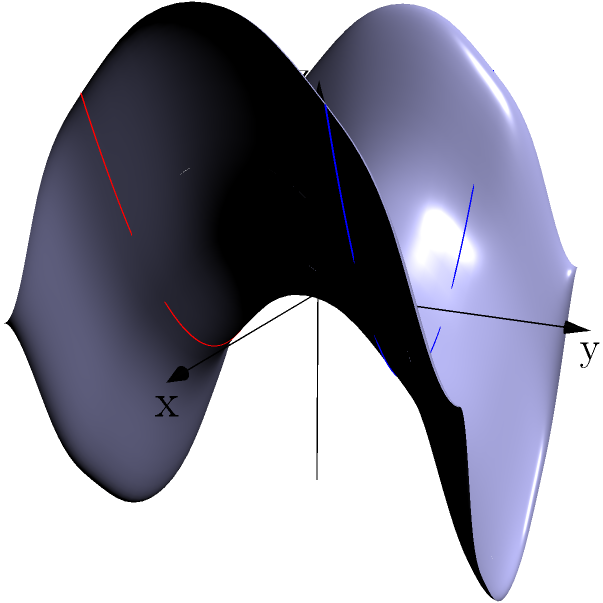On a saddle-shaped surface described by the equation $z = x^2 - y^2$, two lines are drawn parallel to the x-axis at $y = 1$ and $y = -1$. How do these lines behave compared to parallel lines on a flat Euclidean plane? To understand the behavior of these lines, let's follow these steps:

1) In Euclidean geometry, parallel lines maintain a constant distance from each other and never intersect.

2) The saddle surface is described by $z = x^2 - y^2$. This is a hyperbolic paraboloid, a non-Euclidean surface.

3) The two lines are drawn at $y = 1$ and $y = -1$, parallel to the x-axis. Their equations are:
   Line 1: $z = x^2 - 1^2 = x^2 - 1$ at $y = 1$
   Line 2: $z = x^2 - (-1)^2 = x^2 - 1$ at $y = -1$

4) Both lines have the same equation in the xz-plane: $z = x^2 - 1$

5) This means that as x increases or decreases, both lines curve upward in the same way.

6) However, they are on different parts of the saddle surface:
   - The line at $y = 1$ is on the part of the surface that curves upward in the y-direction
   - The line at $y = -1$ is on the part that curves downward in the y-direction

7) As a result, these lines, while starting parallel, actually diverge from each other as you move along the x-axis in either direction.

8) This divergence occurs despite the lines having the same equation in the xz-plane, due to the curvature of the surface in the y-direction.

This behavior is fundamentally different from parallel lines in Euclidean geometry, demonstrating a key property of non-Euclidean geometry on curved surfaces.
Answer: The lines diverge due to the surface's curvature, unlike parallel lines in Euclidean geometry. 